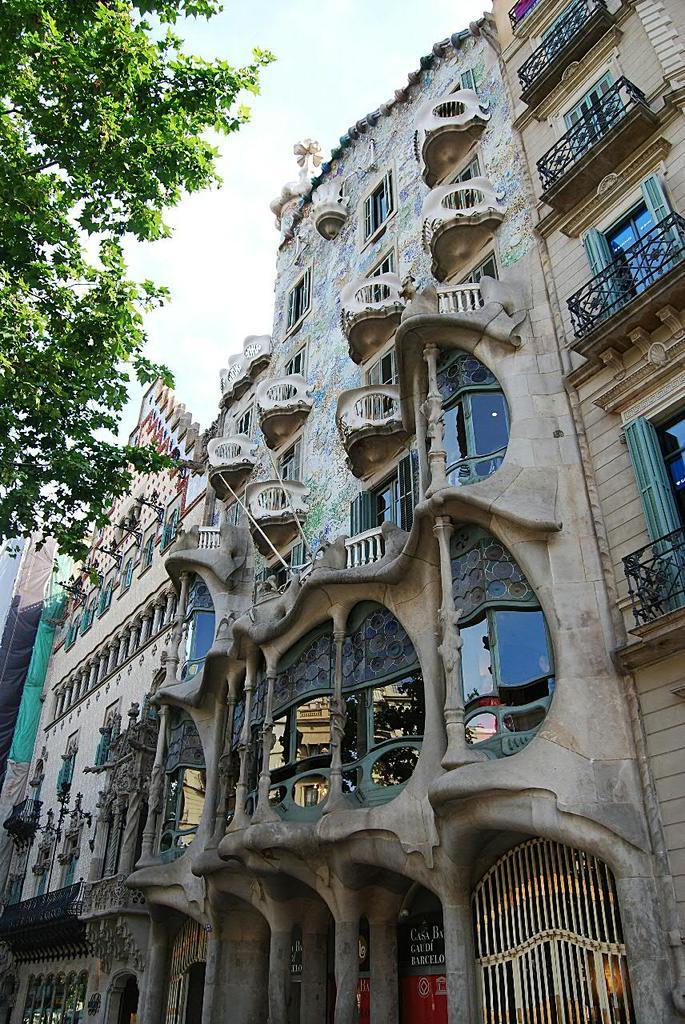How would you summarize this image in a sentence or two? This image is taken outdoors. At the top of the image there is a sky with clouds. On the left side of the image there is a tree. On the right side of the image there are a few buildings with walls, windows, railings, balconies, pillars, roofs, carvings and doors. 